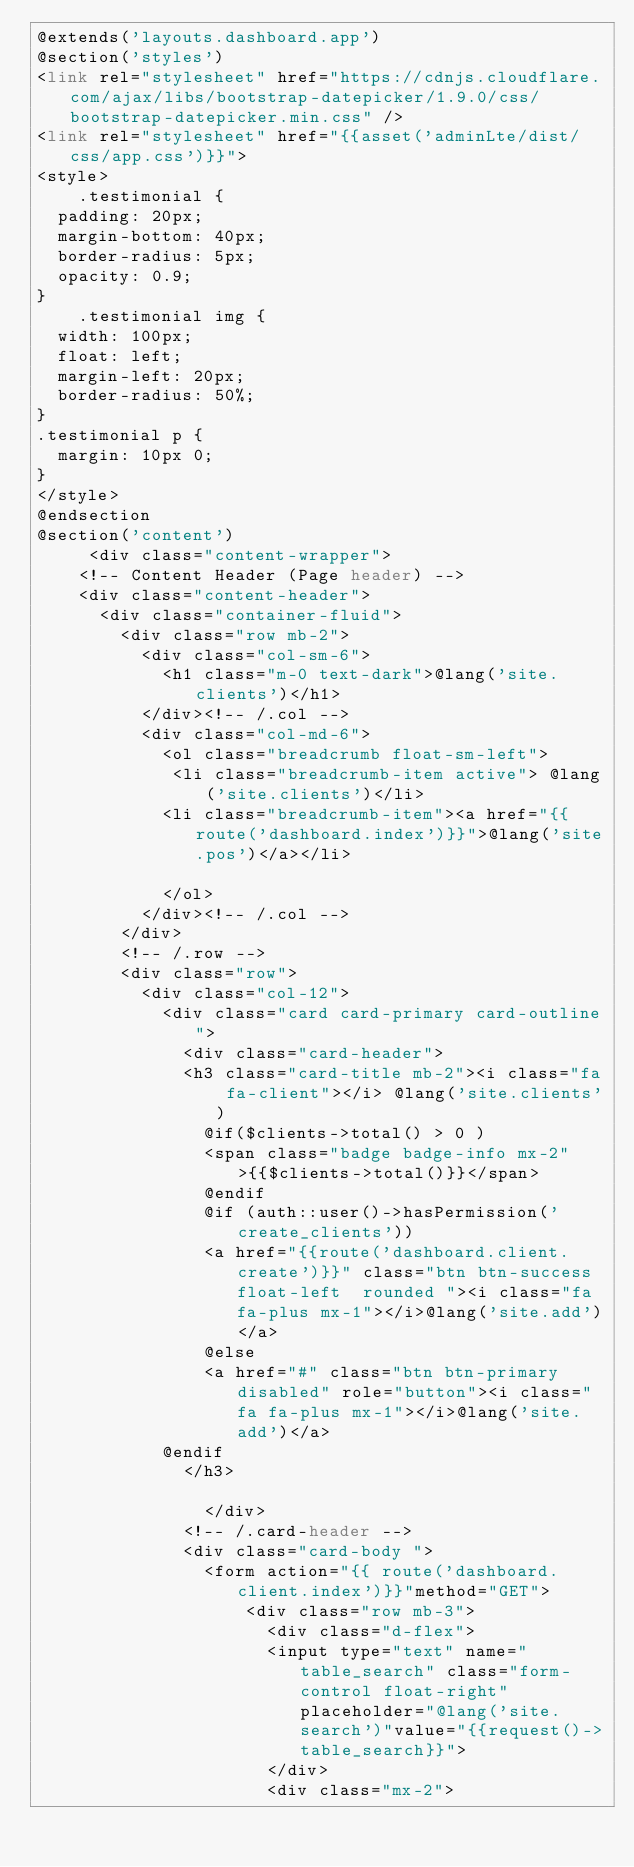Convert code to text. <code><loc_0><loc_0><loc_500><loc_500><_PHP_>@extends('layouts.dashboard.app')
@section('styles')
<link rel="stylesheet" href="https://cdnjs.cloudflare.com/ajax/libs/bootstrap-datepicker/1.9.0/css/bootstrap-datepicker.min.css" />
<link rel="stylesheet" href="{{asset('adminLte/dist/css/app.css')}}">
<style>
    .testimonial {
  padding: 20px;
  margin-bottom: 40px;
  border-radius: 5px;
  opacity: 0.9;
}
    .testimonial img {
  width: 100px;
  float: left;
  margin-left: 20px;
  border-radius: 50%;
}
.testimonial p {
  margin: 10px 0;
}
</style>
@endsection
@section('content')
     <div class="content-wrapper">
    <!-- Content Header (Page header) -->
    <div class="content-header">
      <div class="container-fluid">
        <div class="row mb-2">
          <div class="col-sm-6">
            <h1 class="m-0 text-dark">@lang('site.clients')</h1>
          </div><!-- /.col -->
          <div class="col-md-6">
            <ol class="breadcrumb float-sm-left">
             <li class="breadcrumb-item active"> @lang('site.clients')</li>
            <li class="breadcrumb-item"><a href="{{route('dashboard.index')}}">@lang('site.pos')</a></li>

            </ol>
          </div><!-- /.col -->
        </div>
        <!-- /.row -->
        <div class="row">
          <div class="col-12">
            <div class="card card-primary card-outline">
              <div class="card-header">
              <h3 class="card-title mb-2"><i class="fa fa-client"></i> @lang('site.clients')
                @if($clients->total() > 0 )
                <span class="badge badge-info mx-2" >{{$clients->total()}}</span>
                @endif
                @if (auth::user()->hasPermission('create_clients'))
                <a href="{{route('dashboard.client.create')}}" class="btn btn-success float-left  rounded "><i class="fa fa-plus mx-1"></i>@lang('site.add')</a>
                @else
                <a href="#" class="btn btn-primary disabled" role="button"><i class="fa fa-plus mx-1"></i>@lang('site.add')</a>
            @endif
              </h3>

                </div>
              <!-- /.card-header -->
              <div class="card-body ">
                <form action="{{ route('dashboard.client.index')}}"method="GET">
                    <div class="row mb-3">
                      <div class="d-flex">
                      <input type="text" name="table_search" class="form-control float-right" placeholder="@lang('site.search')"value="{{request()->table_search}}">
                      </div>
                      <div class="mx-2"></code> 